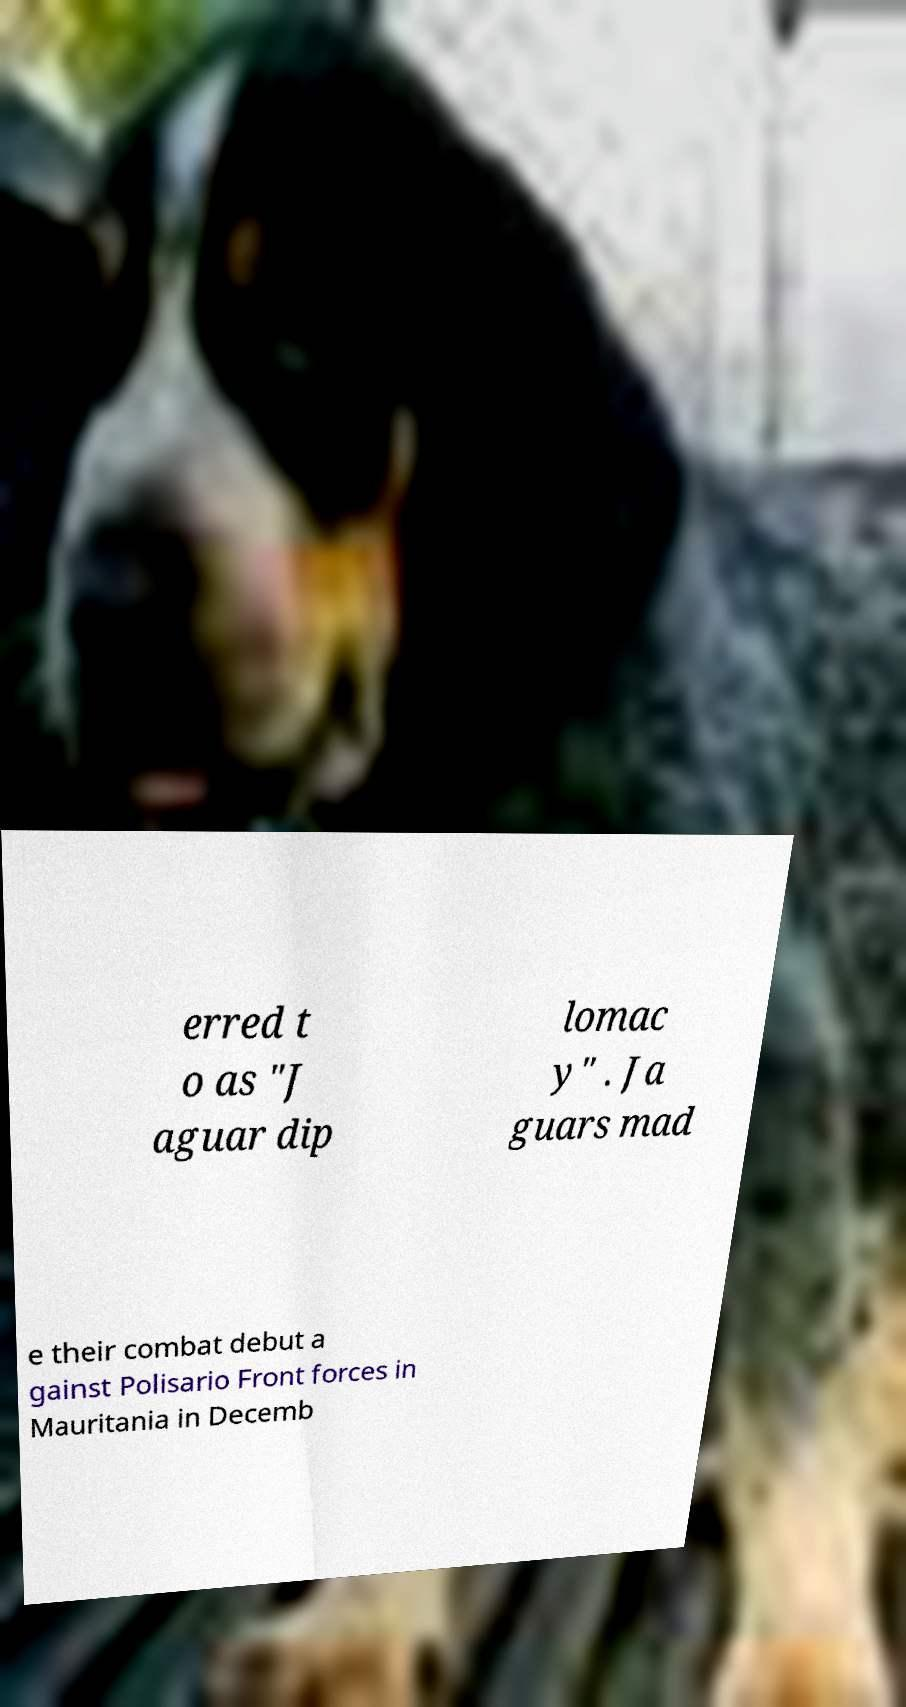Could you assist in decoding the text presented in this image and type it out clearly? erred t o as "J aguar dip lomac y" . Ja guars mad e their combat debut a gainst Polisario Front forces in Mauritania in Decemb 